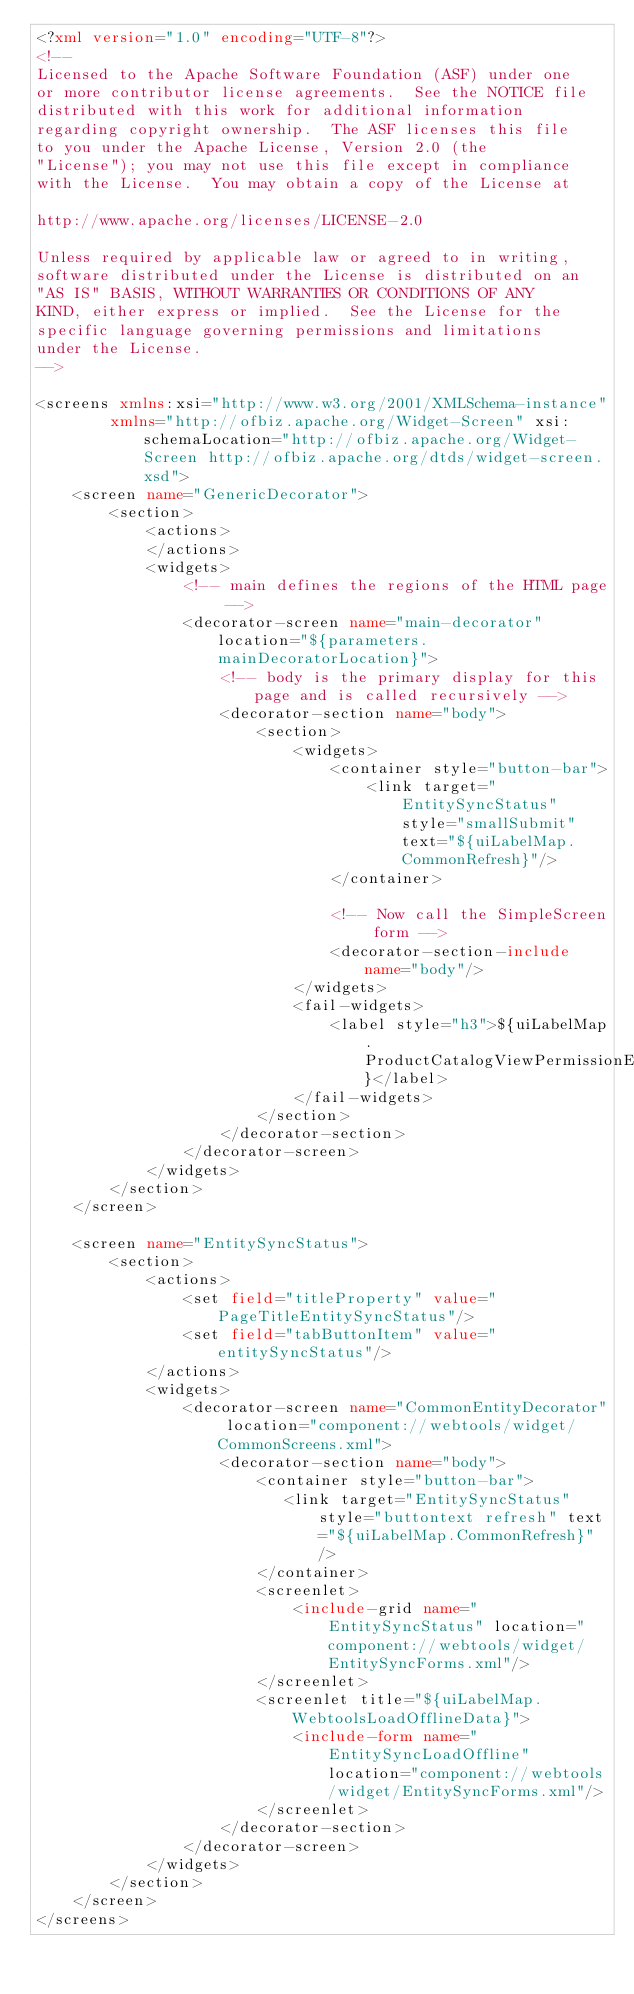Convert code to text. <code><loc_0><loc_0><loc_500><loc_500><_XML_><?xml version="1.0" encoding="UTF-8"?>
<!--
Licensed to the Apache Software Foundation (ASF) under one
or more contributor license agreements.  See the NOTICE file
distributed with this work for additional information
regarding copyright ownership.  The ASF licenses this file
to you under the Apache License, Version 2.0 (the
"License"); you may not use this file except in compliance
with the License.  You may obtain a copy of the License at

http://www.apache.org/licenses/LICENSE-2.0

Unless required by applicable law or agreed to in writing,
software distributed under the License is distributed on an
"AS IS" BASIS, WITHOUT WARRANTIES OR CONDITIONS OF ANY
KIND, either express or implied.  See the License for the
specific language governing permissions and limitations
under the License.
-->

<screens xmlns:xsi="http://www.w3.org/2001/XMLSchema-instance"
        xmlns="http://ofbiz.apache.org/Widget-Screen" xsi:schemaLocation="http://ofbiz.apache.org/Widget-Screen http://ofbiz.apache.org/dtds/widget-screen.xsd">
    <screen name="GenericDecorator">
        <section>
            <actions>
            </actions>
            <widgets>
                <!-- main defines the regions of the HTML page -->
                <decorator-screen name="main-decorator" location="${parameters.mainDecoratorLocation}">
                    <!-- body is the primary display for this page and is called recursively -->
                    <decorator-section name="body">
                        <section>
                            <widgets>
                                <container style="button-bar">
                                    <link target="EntitySyncStatus" style="smallSubmit" text="${uiLabelMap.CommonRefresh}"/>
                                </container>

                                <!-- Now call the SimpleScreen form -->
                                <decorator-section-include name="body"/>
                            </widgets>
                            <fail-widgets>
                                <label style="h3">${uiLabelMap.ProductCatalogViewPermissionError}</label>
                            </fail-widgets>
                        </section>
                    </decorator-section>
                </decorator-screen>
            </widgets>
        </section>
    </screen>

    <screen name="EntitySyncStatus">
        <section>
            <actions>
                <set field="titleProperty" value="PageTitleEntitySyncStatus"/>
                <set field="tabButtonItem" value="entitySyncStatus"/>
            </actions>
            <widgets>
                <decorator-screen name="CommonEntityDecorator" location="component://webtools/widget/CommonScreens.xml">
                    <decorator-section name="body">
                        <container style="button-bar">
                           <link target="EntitySyncStatus" style="buttontext refresh" text="${uiLabelMap.CommonRefresh}"/>
                        </container>
                        <screenlet>
                            <include-grid name="EntitySyncStatus" location="component://webtools/widget/EntitySyncForms.xml"/>
                        </screenlet>
                        <screenlet title="${uiLabelMap.WebtoolsLoadOfflineData}">
                            <include-form name="EntitySyncLoadOffline" location="component://webtools/widget/EntitySyncForms.xml"/>
                        </screenlet>
                    </decorator-section>
                </decorator-screen>
            </widgets>
        </section>
    </screen>
</screens>



</code> 